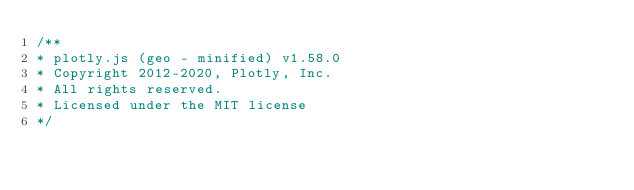<code> <loc_0><loc_0><loc_500><loc_500><_JavaScript_>/**
* plotly.js (geo - minified) v1.58.0
* Copyright 2012-2020, Plotly, Inc.
* All rights reserved.
* Licensed under the MIT license
*/</code> 